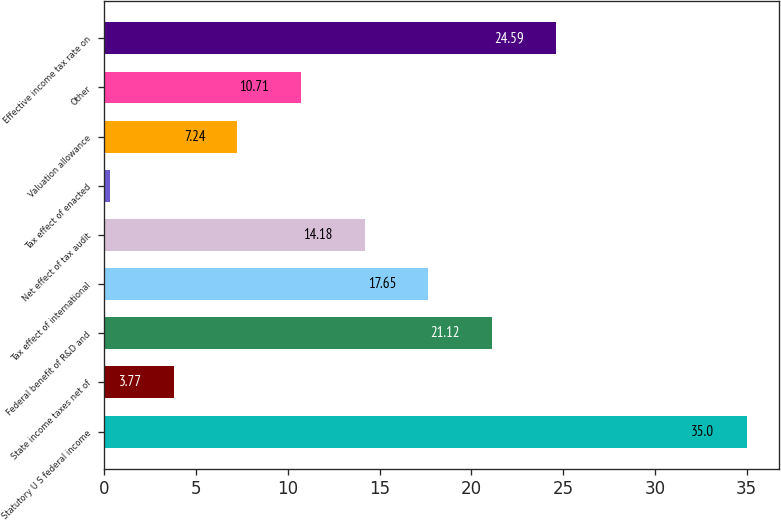<chart> <loc_0><loc_0><loc_500><loc_500><bar_chart><fcel>Statutory U S federal income<fcel>State income taxes net of<fcel>Federal benefit of R&D and<fcel>Tax effect of international<fcel>Net effect of tax audit<fcel>Tax effect of enacted<fcel>Valuation allowance<fcel>Other<fcel>Effective income tax rate on<nl><fcel>35<fcel>3.77<fcel>21.12<fcel>17.65<fcel>14.18<fcel>0.3<fcel>7.24<fcel>10.71<fcel>24.59<nl></chart> 